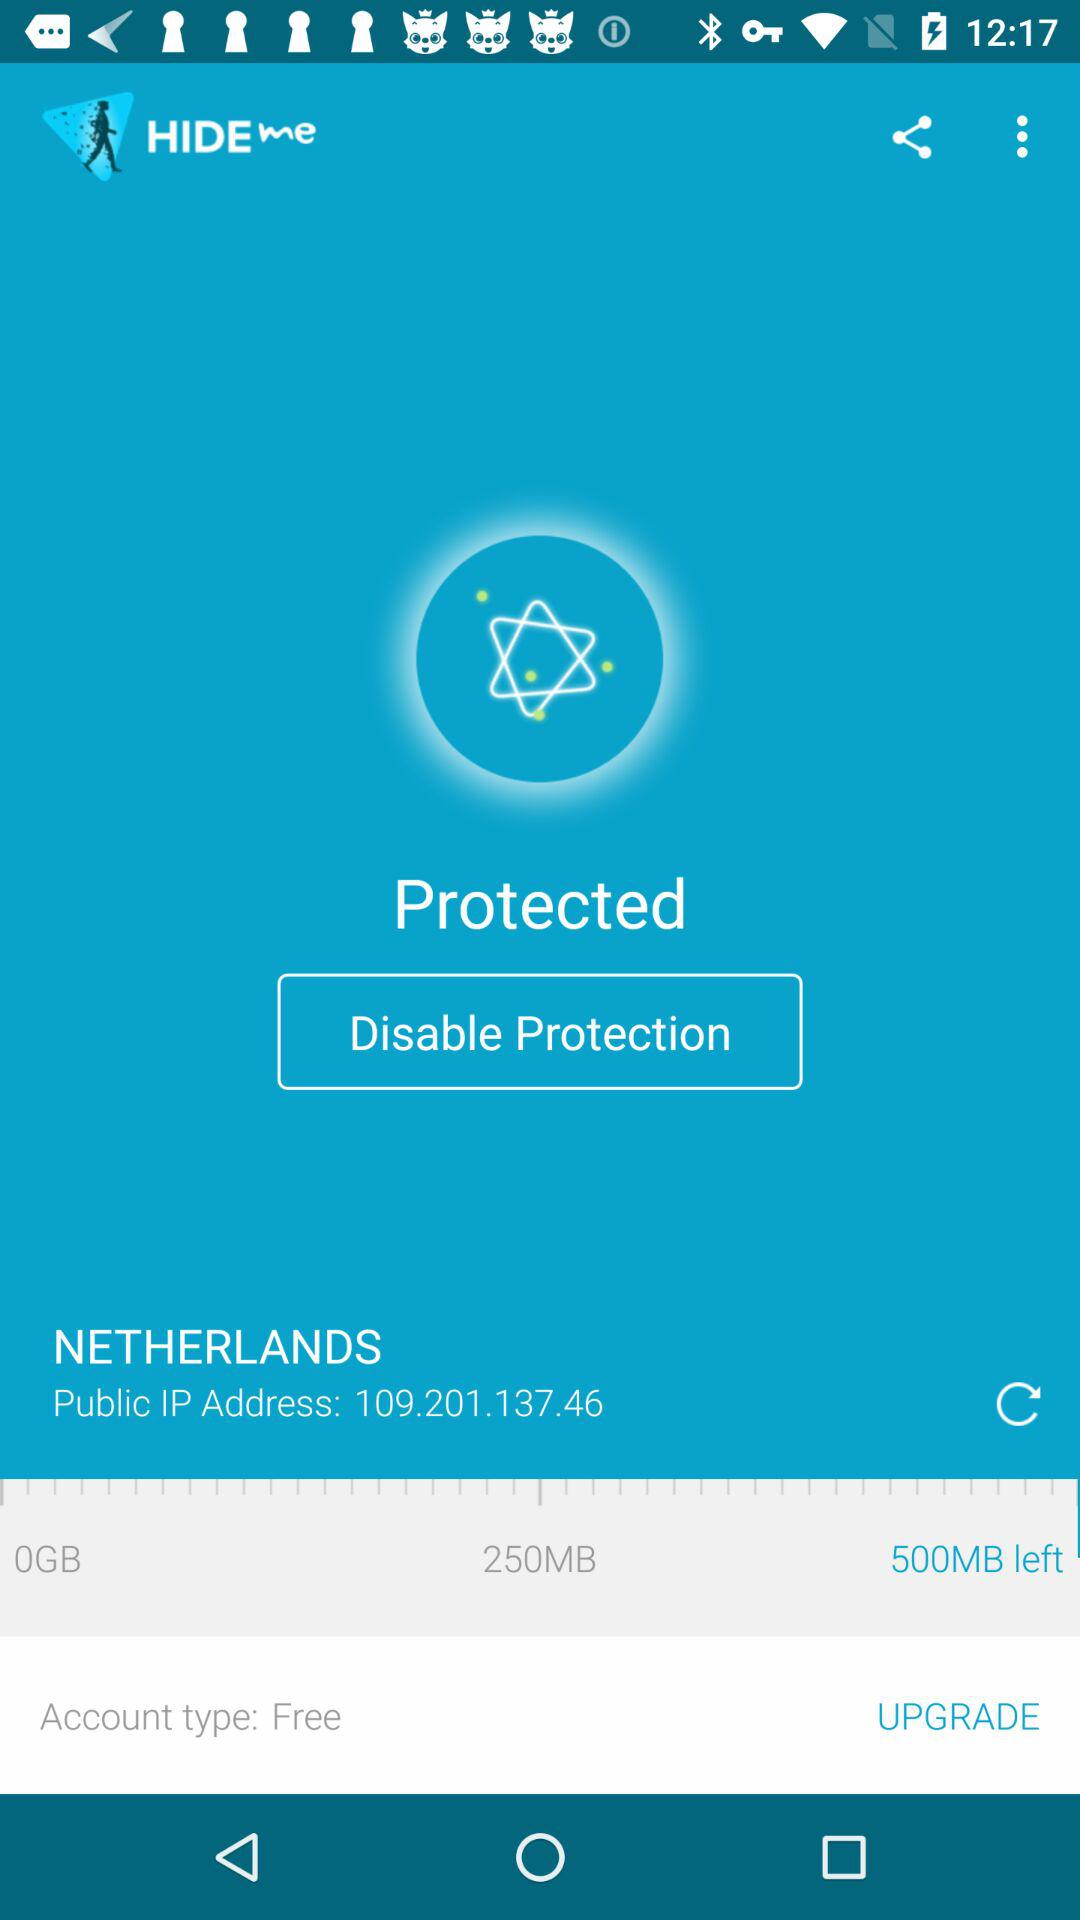What is the selected location? The selected location is the Netherlands. 